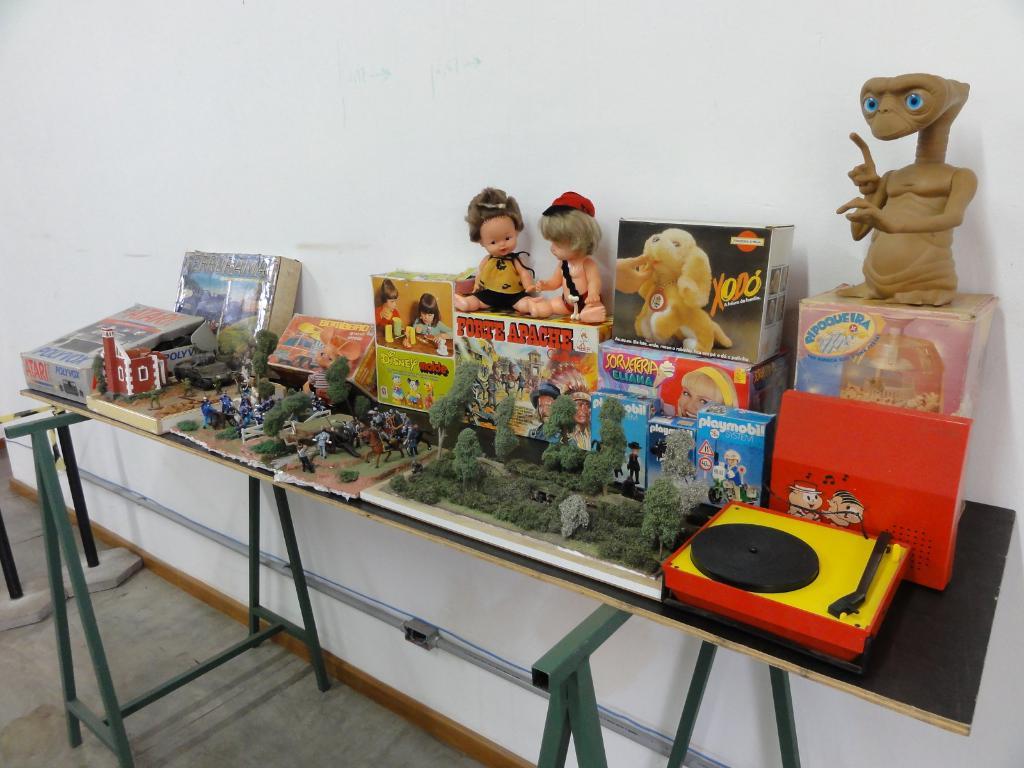What company made the blue box?
Your answer should be compact. Unanswerable. 